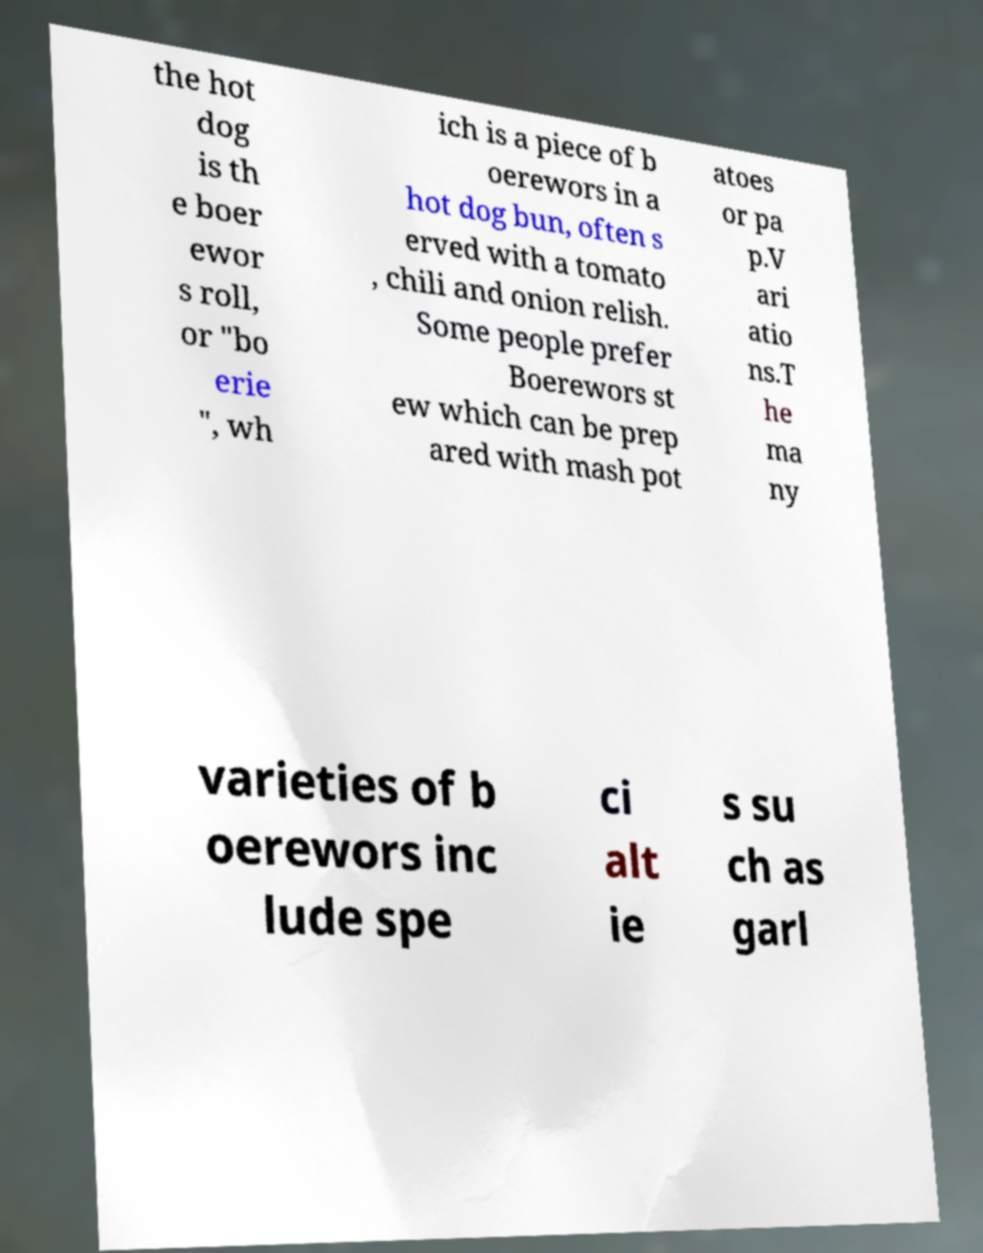What messages or text are displayed in this image? I need them in a readable, typed format. the hot dog is th e boer ewor s roll, or "bo erie ", wh ich is a piece of b oerewors in a hot dog bun, often s erved with a tomato , chili and onion relish. Some people prefer Boerewors st ew which can be prep ared with mash pot atoes or pa p.V ari atio ns.T he ma ny varieties of b oerewors inc lude spe ci alt ie s su ch as garl 